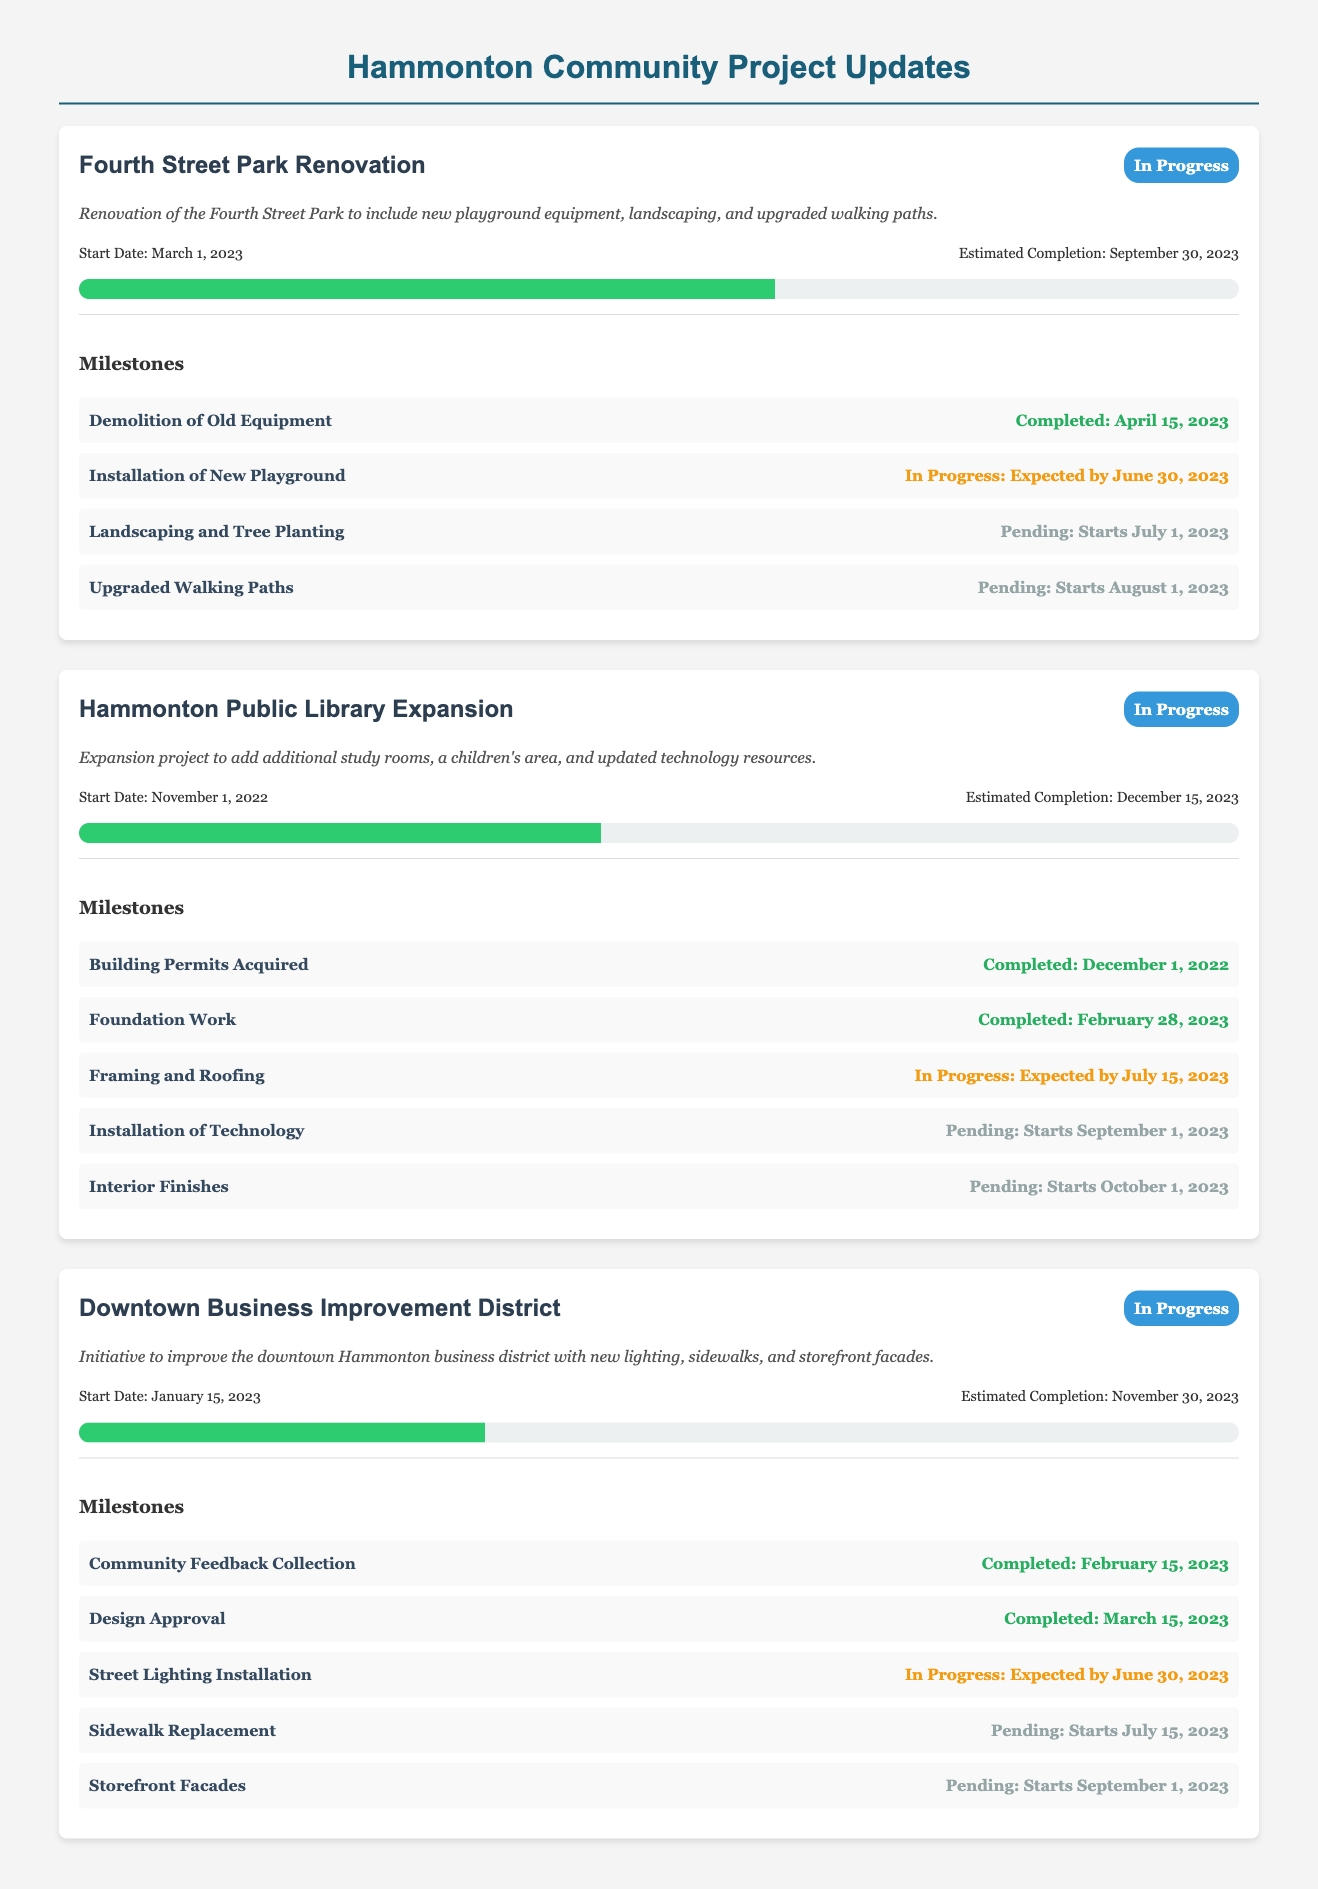What is the project title for the renovation? The project title is displayed prominently at the top of each project section.
Answer: Fourth Street Park Renovation What is the status of the Hammonton Public Library Expansion? The project status is indicated through a status label next to the project title.
Answer: In Progress What is the estimated completion date for the Downtown Business Improvement District? The estimated completion date is shown alongside the start date and is part of the project timeline.
Answer: November 30, 2023 What milestone was completed for the Fourth Street Park Renovation? Each project includes a list of milestones with their completion status and dates.
Answer: Demolition of Old Equipment How much of the Hammonton Public Library Expansion is complete? The progress percentage is represented visually in the progress bar for each project.
Answer: 45% What is the expected completion date for the installation of the new playground? The expected completion date is mentioned in the milestone details for each project.
Answer: June 30, 2023 Which project has landscaping planned to start on July 1, 2023? The details of when various milestone tasks start are outlined under each project's milestones.
Answer: Fourth Street Park Renovation What is the start date for the Downtown Business Improvement District? The start date is provided in the project timeline section for each project.
Answer: January 15, 2023 What type of document is this? The structure and purpose of the information presented indicates the category of the document.
Answer: Community Project Updates 